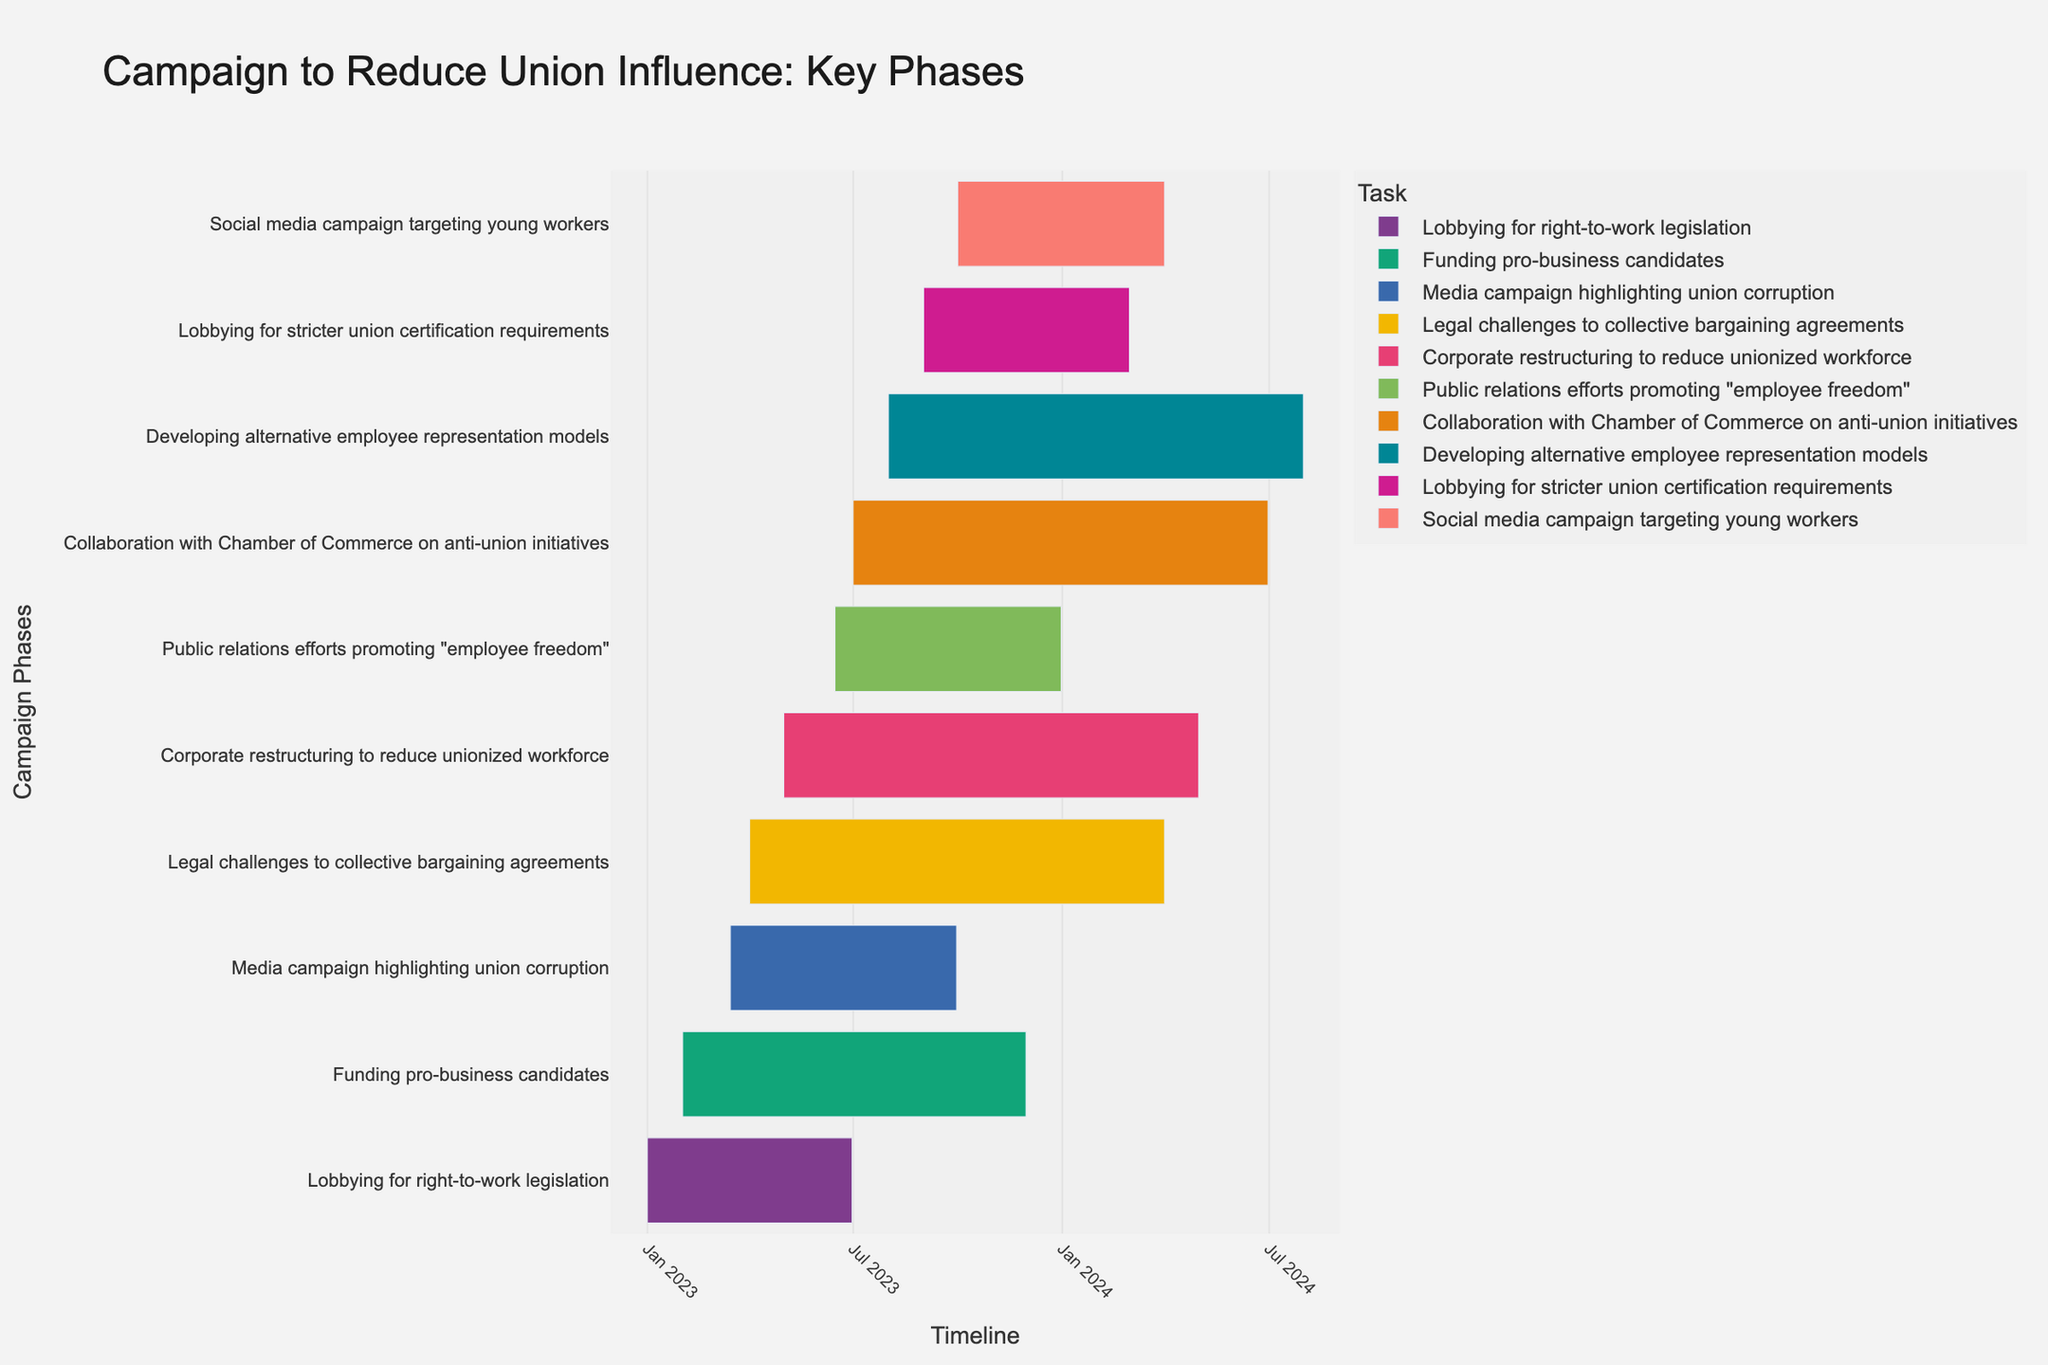What is the title of the Gantt chart? The title is usually found at the top center of the chart and provides a brief description of its content.
Answer: Campaign to Reduce Union Influence: Key Phases When does the "Media campaign highlighting union corruption" phase end? Look at the bar labeled "Media campaign highlighting union corruption" and find the endpoint of the bar on the timeline.
Answer: 2023-09-30 Which task starts first in the campaign? Identify the task bar that has the earliest start date along the timeline axis.
Answer: Lobbying for right-to-work legislation Which two tasks overlap the most in their timelines? Observe the bars on the chart and find the pair that has the greatest period of overlap.
Answer: Media campaign highlighting union corruption and Funding pro-business candidates How long does the "Corporate restructuring to reduce unionized workforce" phase last? Calculate the difference between the start and end dates to determine the duration.
Answer: Approximately 12 months Which phase has the latest end date? Identify the task bar that extends furthest to the right on the timeline axis.
Answer: Developing alternative employee representation models Are there any phases that start in June 2023? Check the timeline axis for June 2023 and see if any task bars begin in that month.
Answer: Yes, Public relations efforts promoting "employee freedom" When does the "Social media campaign targeting young workers" start and end? Look at the "Social media campaign targeting young workers" task bar and note its start and end points on the timeline axis.
Answer: Starts on 2023-10-01 and ends on 2024-03-31 Which task has the shortest duration and how long is it? Compare the lengths of all task bars to find the shortest one and calculate its duration.
Answer: Lobbying for stricter union certification requirements, approximately 6 months How many phases are active during December 2023? Identify all task bars that extend through December 2023 and count them.
Answer: 6 